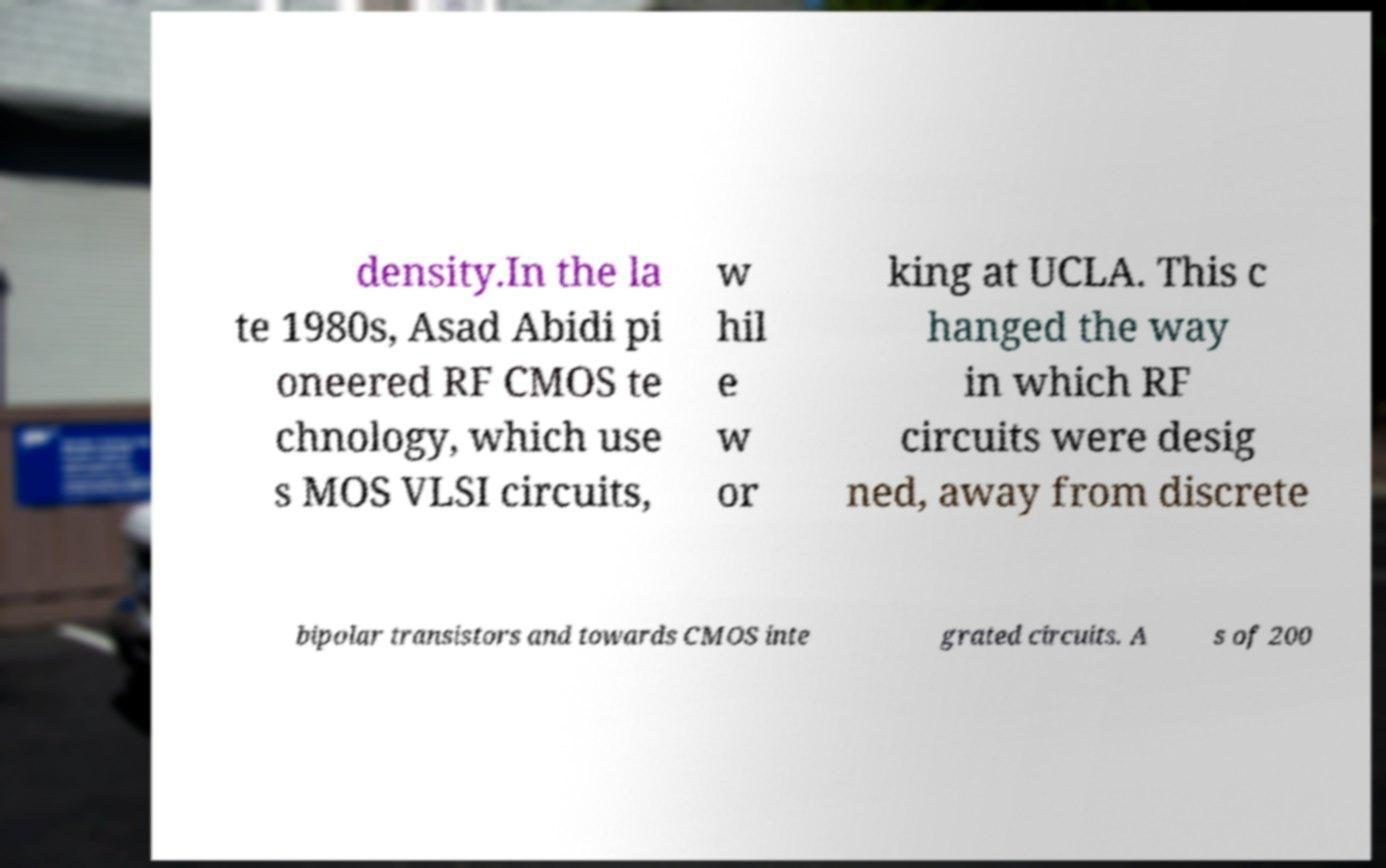For documentation purposes, I need the text within this image transcribed. Could you provide that? density.In the la te 1980s, Asad Abidi pi oneered RF CMOS te chnology, which use s MOS VLSI circuits, w hil e w or king at UCLA. This c hanged the way in which RF circuits were desig ned, away from discrete bipolar transistors and towards CMOS inte grated circuits. A s of 200 